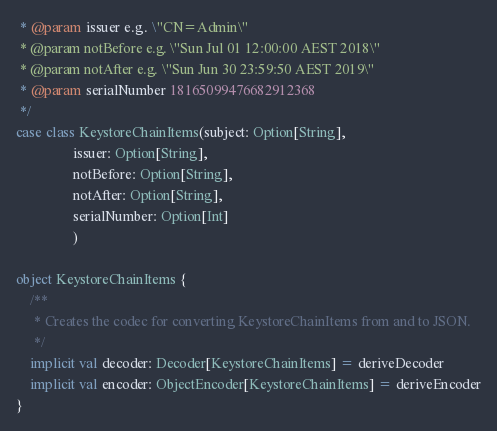Convert code to text. <code><loc_0><loc_0><loc_500><loc_500><_Scala_> * @param issuer e.g. \"CN=Admin\"
 * @param notBefore e.g. \"Sun Jul 01 12:00:00 AEST 2018\"
 * @param notAfter e.g. \"Sun Jun 30 23:59:50 AEST 2019\"
 * @param serialNumber 18165099476682912368
 */
case class KeystoreChainItems(subject: Option[String],
                issuer: Option[String],
                notBefore: Option[String],
                notAfter: Option[String],
                serialNumber: Option[Int]
                )

object KeystoreChainItems {
    /**
     * Creates the codec for converting KeystoreChainItems from and to JSON.
     */
    implicit val decoder: Decoder[KeystoreChainItems] = deriveDecoder
    implicit val encoder: ObjectEncoder[KeystoreChainItems] = deriveEncoder
}
</code> 